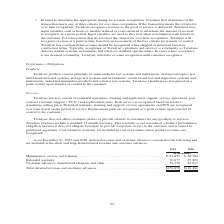According to Teradyne's financial document, What does Teradyne services consist of? extended warranties, training and application support, service agreement, post contract customer support (“PCS”) and replacement parts. The document states: "Teradyne services consist of extended warranties, training and application support, service agreement, post contract customer support (“PCS”) and repl..." Also, Where are deferred revenue and customer advances included in? the short and long-term deferred revenue and customer advances. The document states: "es consisted of the following and are included in the short and long-term deferred revenue and customer advances:..." Also, In which years were Total deferred revenue and customer advances calculated? The document shows two values: 2019 and 2018. From the document: "2019 2018 2019 2018..." Additionally, In which year was Maintenance, service and training larger? According to the financial document, 2019. The relevant text states: "2019 2018..." Also, can you calculate: What was the change in Extended warranty from 2018 to 2019? Based on the calculation: 30,677-27,422, the result is 3255 (in thousands). This is based on the information: "ng . $ 63,815 $ 58,362 Extended warranty . 30,677 27,422 Customer advances, undelivered elements and other . 56,358 24,677 training . $ 63,815 $ 58,362 Extended warranty . 30,677 27,422 Customer advan..." The key data points involved are: 27,422, 30,677. Also, can you calculate: What was the percentage change in Extended warranty from 2018 to 2019? To answer this question, I need to perform calculations using the financial data. The calculation is: (30,677-27,422)/27,422, which equals 11.87 (percentage). This is based on the information: "ng . $ 63,815 $ 58,362 Extended warranty . 30,677 27,422 Customer advances, undelivered elements and other . 56,358 24,677 training . $ 63,815 $ 58,362 Extended warranty . 30,677 27,422 Customer advan..." The key data points involved are: 27,422, 30,677. 